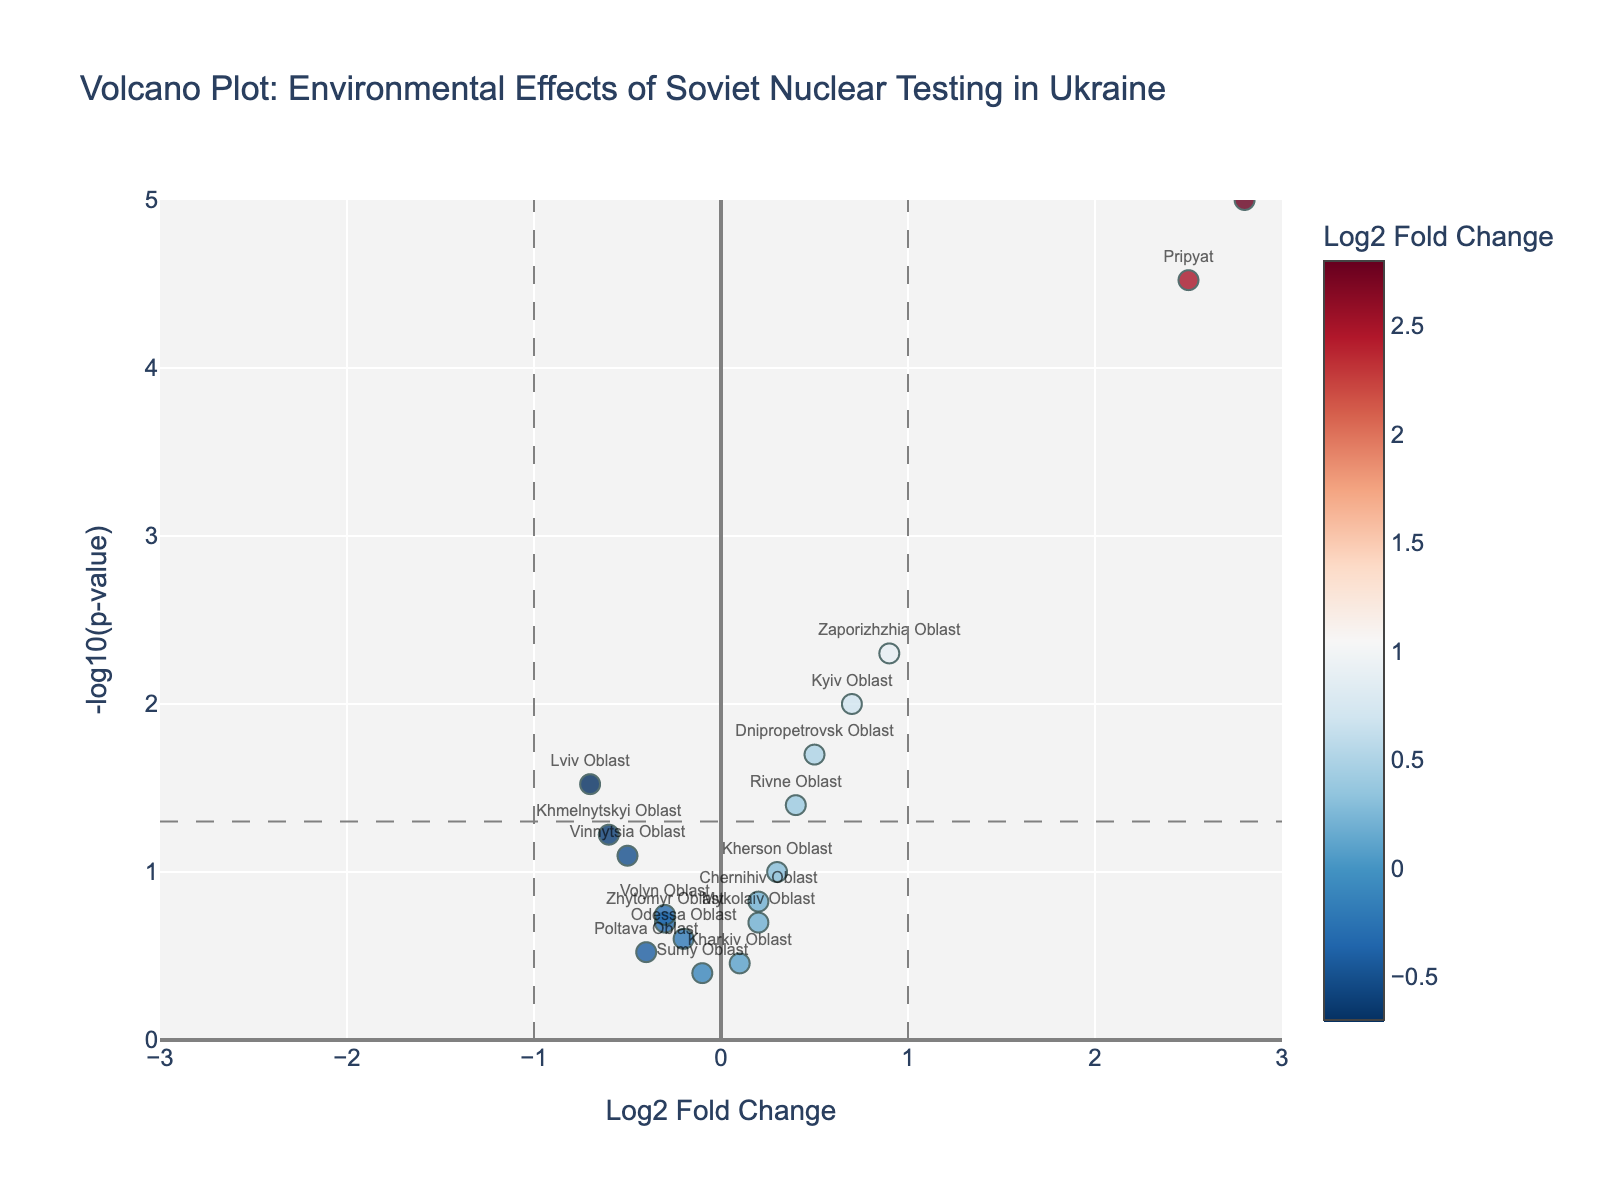What is the title of the Volcano Plot? The title of a plot is usually at the top and provides a brief description of the data being visualized.
Answer: Volcano Plot: Environmental Effects of Soviet Nuclear Testing in Ukraine How many regions have a statistically significant change in radiation levels? Statistical significance is typically set at p < 0.05, which corresponds to a -log10(p-value) greater than 1.3. By counting the data points above the horizontal line (significance threshold) at 1.3, we find the number of significant regions.
Answer: 8 Which region has the highest Log2 Fold Change? To find the highest Log2 Fold Change, look for the data point furthest to the right. The region corresponding to this point is the one with the highest value.
Answer: Chernobyl Exclusion Zone Which region has the lowest Log2 Fold Change? To find the lowest Log2 Fold Change, look for the data point furthest to the left. The region corresponding to this point is the one with the lowest value.
Answer: Lviv Oblast What is the Log2 Fold Change and p-value for Pripyat? Locate the data point associated with Pripyat using the hover text or labels. The Log2 Fold Change and p-value can be found directly from this point's hover text.
Answer: Log2FoldChange: 2.5, p-value: 0.00003 Which regions have a Log2 Fold Change close to zero but are statistically significant? Statistically significant regions have -log10(p) > 1.3. From these, select the ones with Log2 Fold Change (x-axis) values close to zero.
Answer: Kyiv Oblast and Zaporizhzhia Oblast How many regions have a p-value greater than 0.1 but less than 0.2? P-values corresponding to -log10(p-value) between approximately 0.7 and 1 should be counted. Verify by checking these counts on the y-axis.
Answer: 4 How does the radiation level change in Chernivtsi Oblast compare to Dnipropetrovsk Oblast? First, identify each region's data point. Compare their Log2 Fold Change values to understand the direction and magnitude of radiation level changes.
Answer: Chernivtsi Oblast: increases more (2.8), Dnipropetrovsk Oblast: increases less (0.5) What does the color of a data point represent in this plot? Observe the color bar on the right of the plot, which usually indicates what the colors represent. In this case, it aligns with the Log2 Fold Change values.
Answer: Log2 Fold Change Are there any regions where the radiation levels have decreased significantly? A significant decrease would be noted as a negative Log2 Fold Change with -log10(p-value) > 1.3, meaning the point is left of zero and above the significance threshold.
Answer: Lviv Oblast 